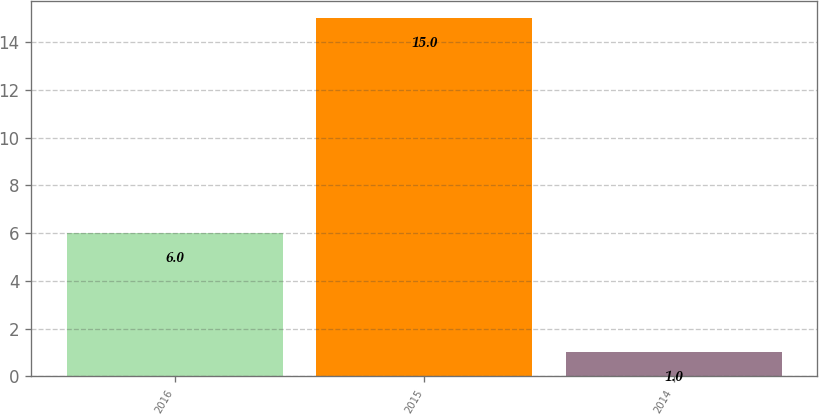Convert chart to OTSL. <chart><loc_0><loc_0><loc_500><loc_500><bar_chart><fcel>2016<fcel>2015<fcel>2014<nl><fcel>6<fcel>15<fcel>1<nl></chart> 